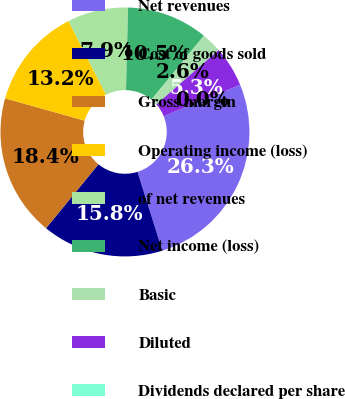<chart> <loc_0><loc_0><loc_500><loc_500><pie_chart><fcel>Net revenues<fcel>Cost of goods sold<fcel>Gross margin<fcel>Operating income (loss)<fcel>of net revenues<fcel>Net income (loss)<fcel>Basic<fcel>Diluted<fcel>Dividends declared per share<nl><fcel>26.32%<fcel>15.79%<fcel>18.42%<fcel>13.16%<fcel>7.89%<fcel>10.53%<fcel>2.63%<fcel>5.26%<fcel>0.0%<nl></chart> 